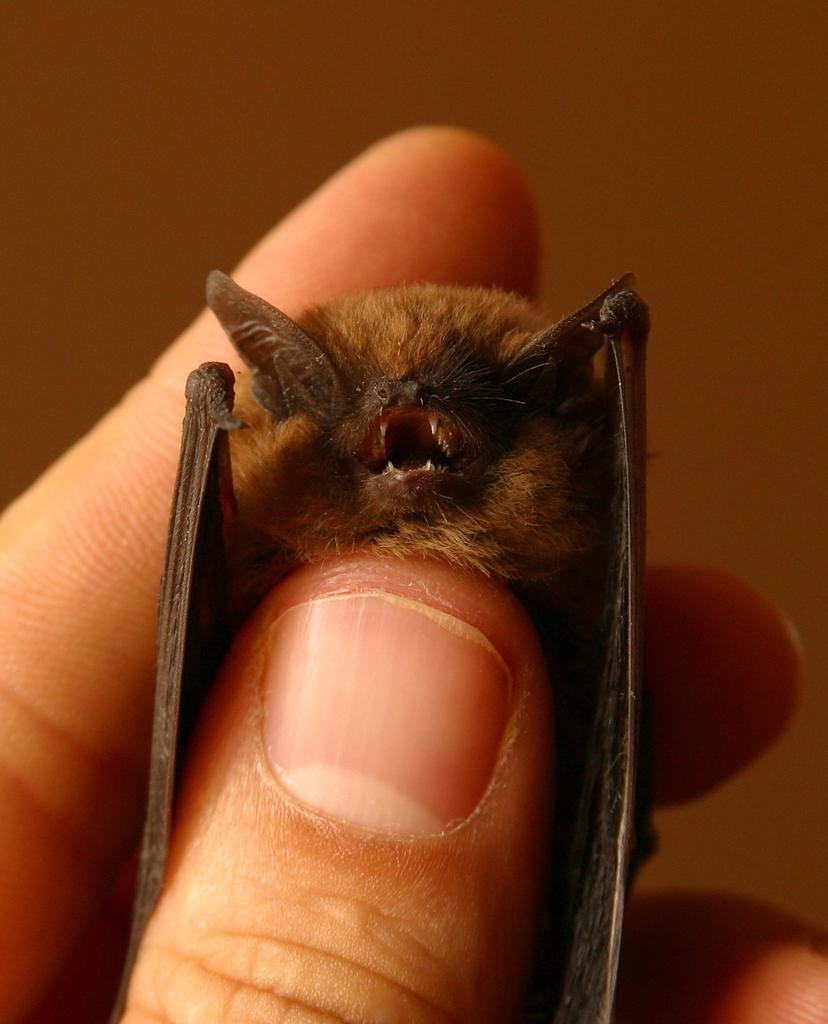What is the person holding in the image? There is a person's hand holding a black bat in the image. What can be seen at the top of the image? There is a wall at the top of the image. What type of knife is being used to cut the roof in the image? There is no knife or roof present in the image; it only features a person's hand holding a black bat and a wall at the top. 